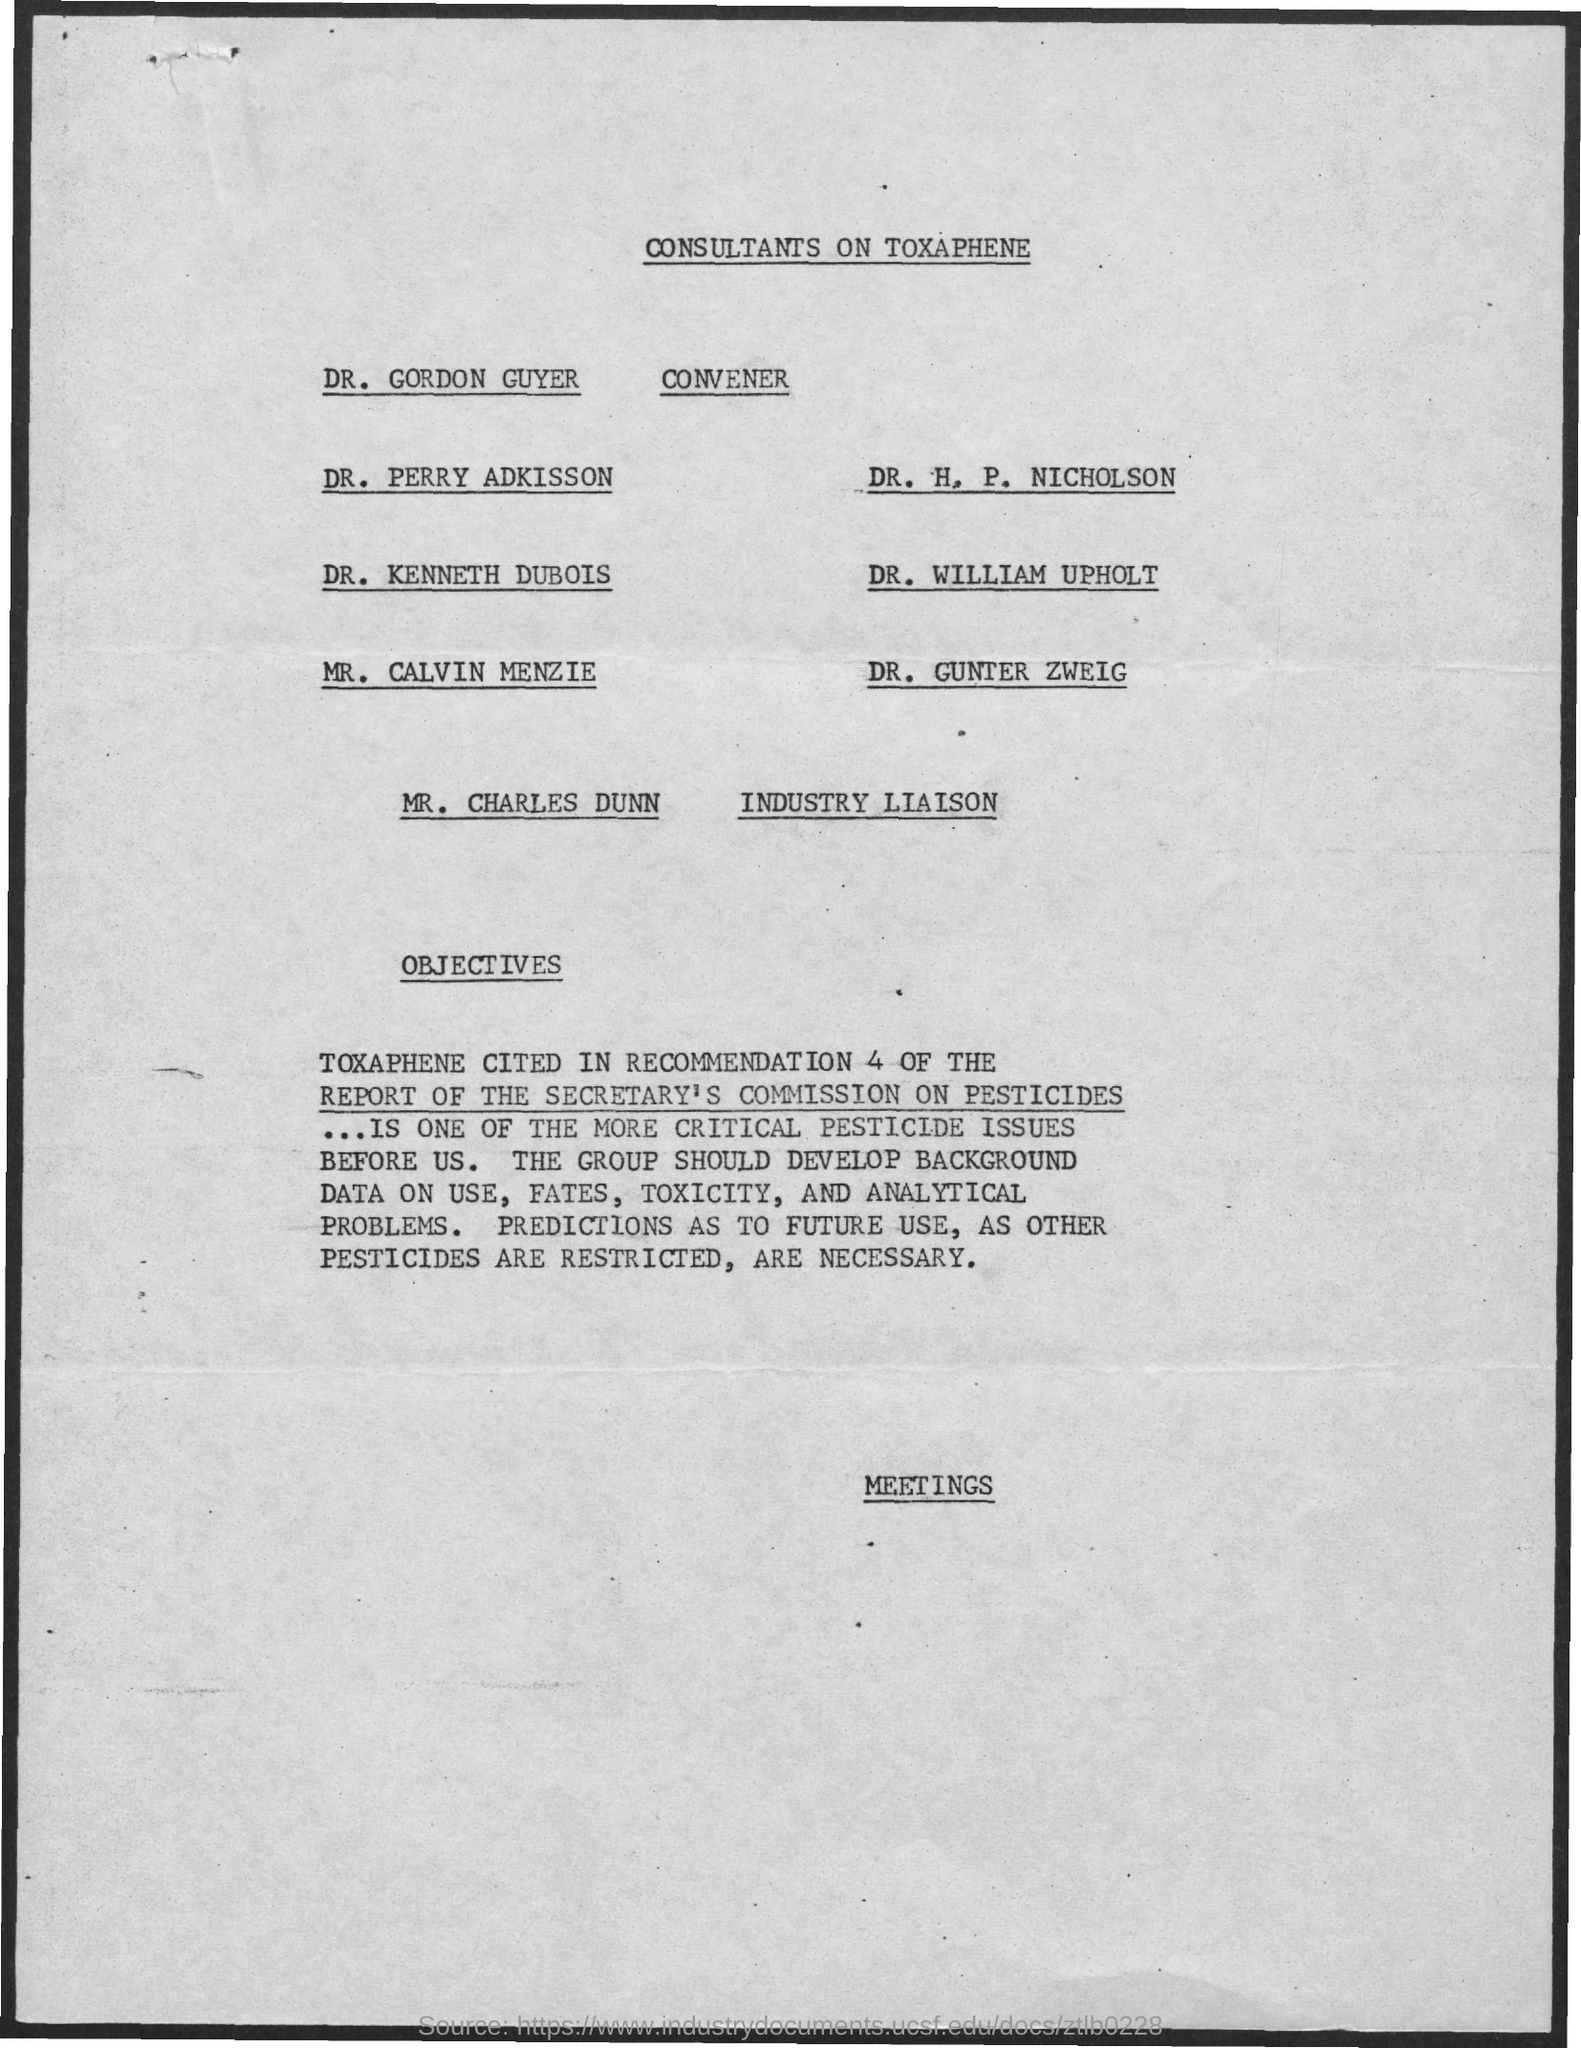What is the title of the document?
Provide a short and direct response. Consultants on toxaphene. Who is the Convener?
Ensure brevity in your answer.  DR. Gordon Guyer. Who is the Industry Liaison?
Ensure brevity in your answer.  Mr. charles dunn. 